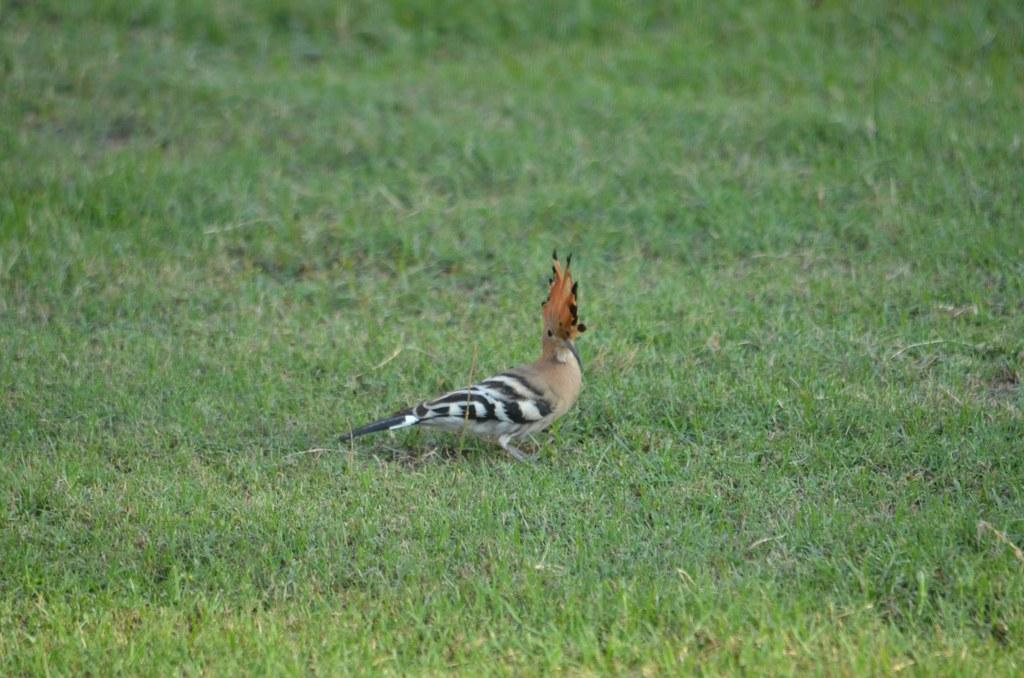What type of ground is visible in the image? There is grass ground in the image. What animal can be seen on the grass ground? There is a bird on the grass ground. Can you describe the bird's appearance in the image? The bird has a color pattern of cream, orange, black, and white. Where is the sofa located in the image? There is no sofa present in the image. How many tomatoes are growing on the grass ground in the image? There are no tomatoes visible in the image; it features a bird on the grass ground. 